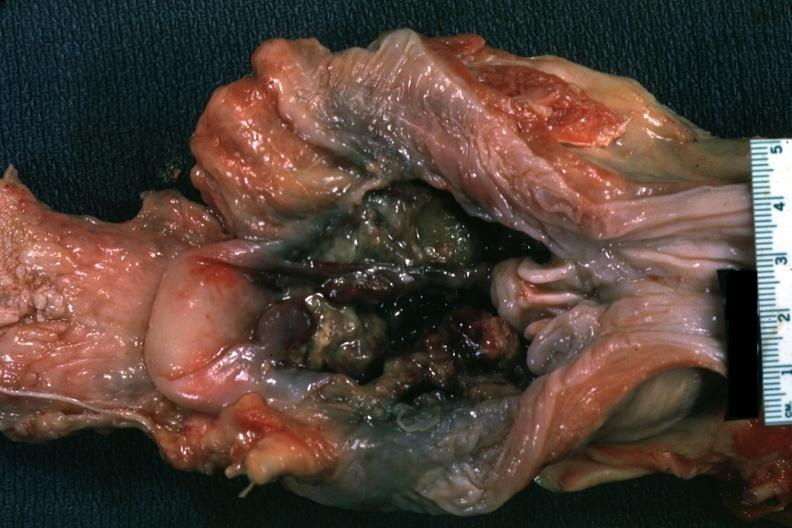s oral present?
Answer the question using a single word or phrase. Yes 